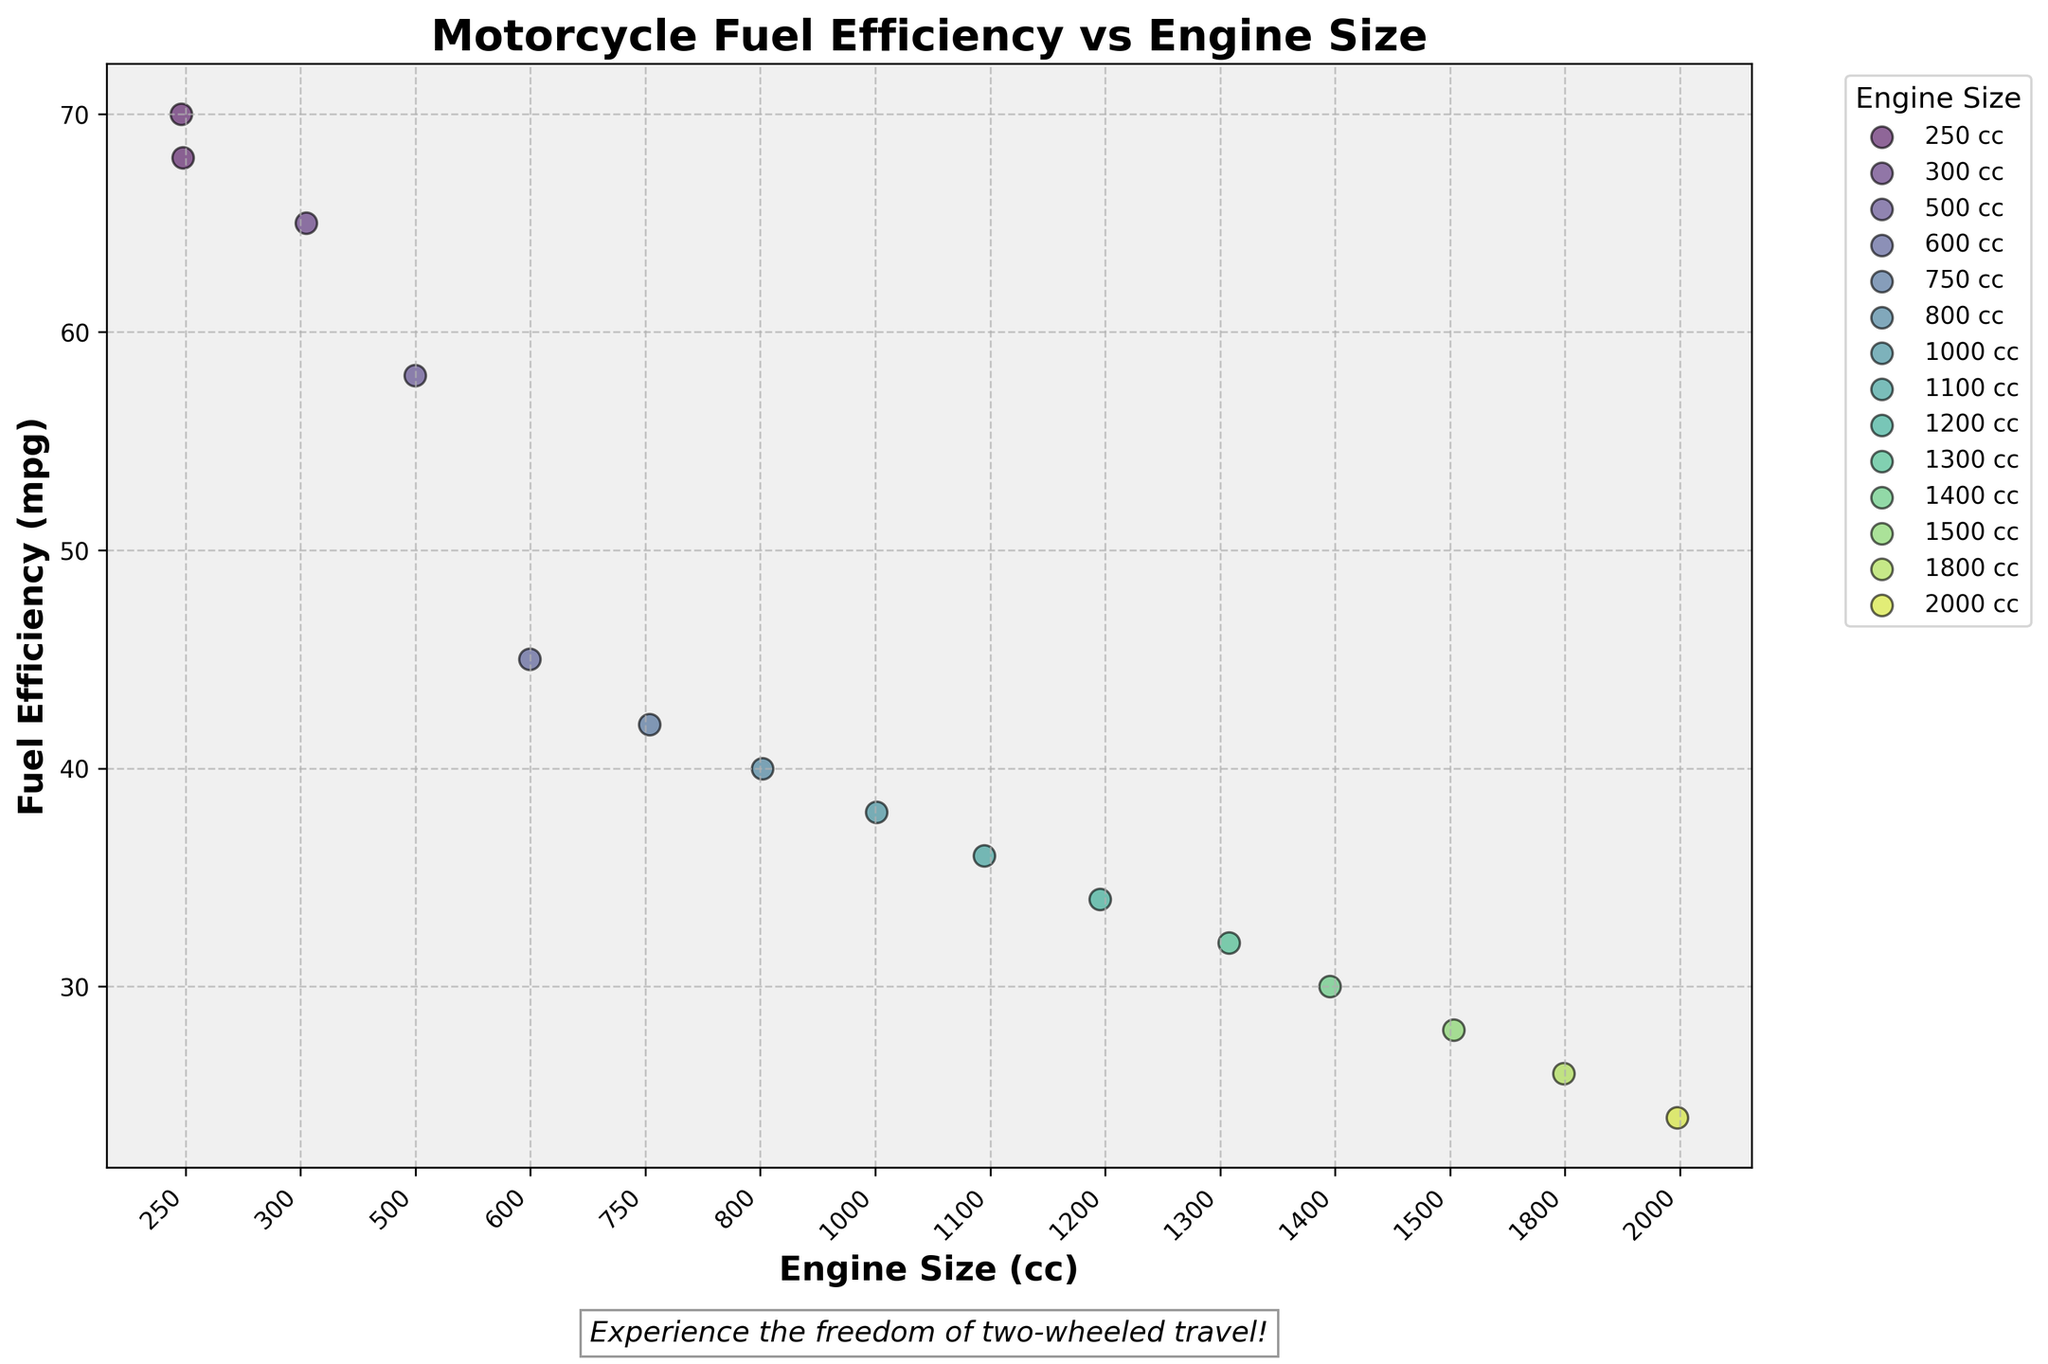What's the title of the plot? The title is the text displayed at the top of the figure. In this case, it should clearly state the relationship being analyzed.
Answer: Motorcycle Fuel Efficiency vs Engine Size What's on the x-axis? The x-axis shows the variable we are comparing across different groups. Here, it represents the engine size of motorcycles in cubic centimeters (cc).
Answer: Engine Size (cc) How many different engine sizes are represented in the plot? By counting the unique categories on the x-axis, we identify the number of distinct engine sizes that are analyzed in the plot.
Answer: 15 Which motorcycle model has the highest fuel efficiency? To find this, locate the highest point on the y-axis and identify the label associated with it.
Answer: Honda CBR250R Which motorcycle model has the lowest fuel efficiency? To determine this, locate the lowest point on the y-axis and find the corresponding label.
Answer: Boss Hoss V8 What's the range of fuel efficiencies for models with 250 cc engines? Identify the points corresponding to 250 cc and look at the spread of the y-values to determine the range. The models for 250 cc are Honda CBR250R and Yamaha YZF-R3. Their fuel efficiencies are 70 mpg and 68 mpg, respectively.
Answer: 68–70 mpg Compare the fuel efficiency of models with 750 cc and 1000 cc engines. Which one is more efficient? Compare the average positions of the points at 750 cc and 1000 cc on the y-axis. The 750 cc Suzuki GSX-S750 has 42 mpg, while the 1000 cc Ducati Monster 1200 has 38 mpg.
Answer: 750 cc (42 mpg) What trend can you observe between engine size and fuel efficiency? Look for a pattern in how the y-values (fuel efficiency) change as the x-values (engine size) increase. Generally, larger engine sizes result in lower fuel efficiencies.
Answer: Larger engine sizes tend to have lower fuel efficiency Is there any engine size category with multiple models having the same fuel efficiency? Examine each engine size category and see if there are multiple points that align exactly on the y-axis. No two motorcycles have the exact same fuel efficiency values here.
Answer: No What color represents the highest engine size, and does it show higher or lower fuel efficiency compared to lower engine sizes? Identify the color representing the highest engine size (2000 cc) and compare the y-value to those of lower engine sizes. The 2000 cc engine is shown in a specific color at the lowest end of the y-axis (24 mpg).
Answer: Lower fuel efficiency (24 mpg) 